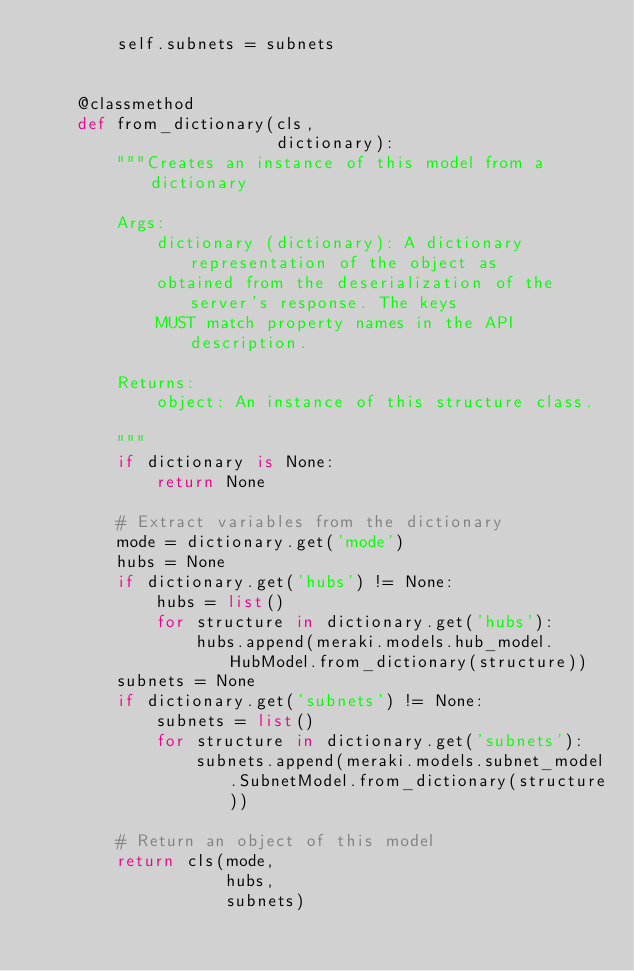<code> <loc_0><loc_0><loc_500><loc_500><_Python_>        self.subnets = subnets


    @classmethod
    def from_dictionary(cls,
                        dictionary):
        """Creates an instance of this model from a dictionary

        Args:
            dictionary (dictionary): A dictionary representation of the object as
            obtained from the deserialization of the server's response. The keys
            MUST match property names in the API description.

        Returns:
            object: An instance of this structure class.

        """
        if dictionary is None:
            return None

        # Extract variables from the dictionary
        mode = dictionary.get('mode')
        hubs = None
        if dictionary.get('hubs') != None:
            hubs = list()
            for structure in dictionary.get('hubs'):
                hubs.append(meraki.models.hub_model.HubModel.from_dictionary(structure))
        subnets = None
        if dictionary.get('subnets') != None:
            subnets = list()
            for structure in dictionary.get('subnets'):
                subnets.append(meraki.models.subnet_model.SubnetModel.from_dictionary(structure))

        # Return an object of this model
        return cls(mode,
                   hubs,
                   subnets)


</code> 